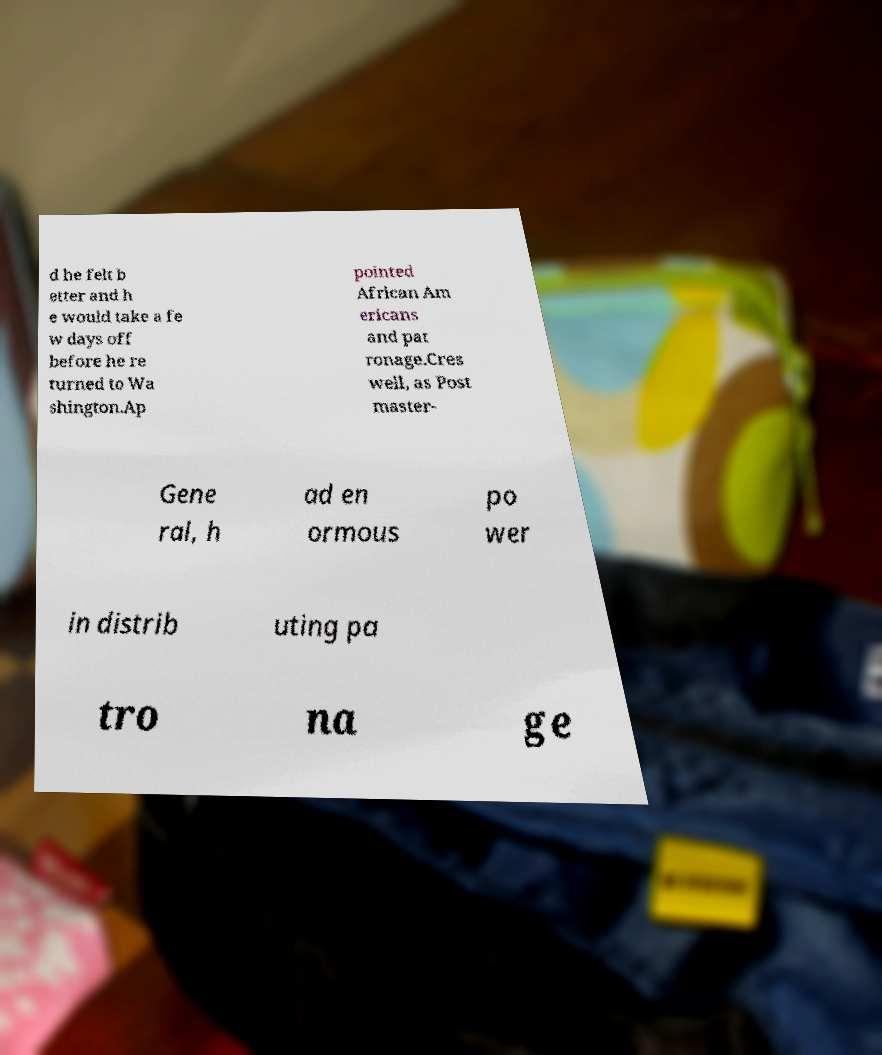For documentation purposes, I need the text within this image transcribed. Could you provide that? d he felt b etter and h e would take a fe w days off before he re turned to Wa shington.Ap pointed African Am ericans and pat ronage.Cres well, as Post master- Gene ral, h ad en ormous po wer in distrib uting pa tro na ge 